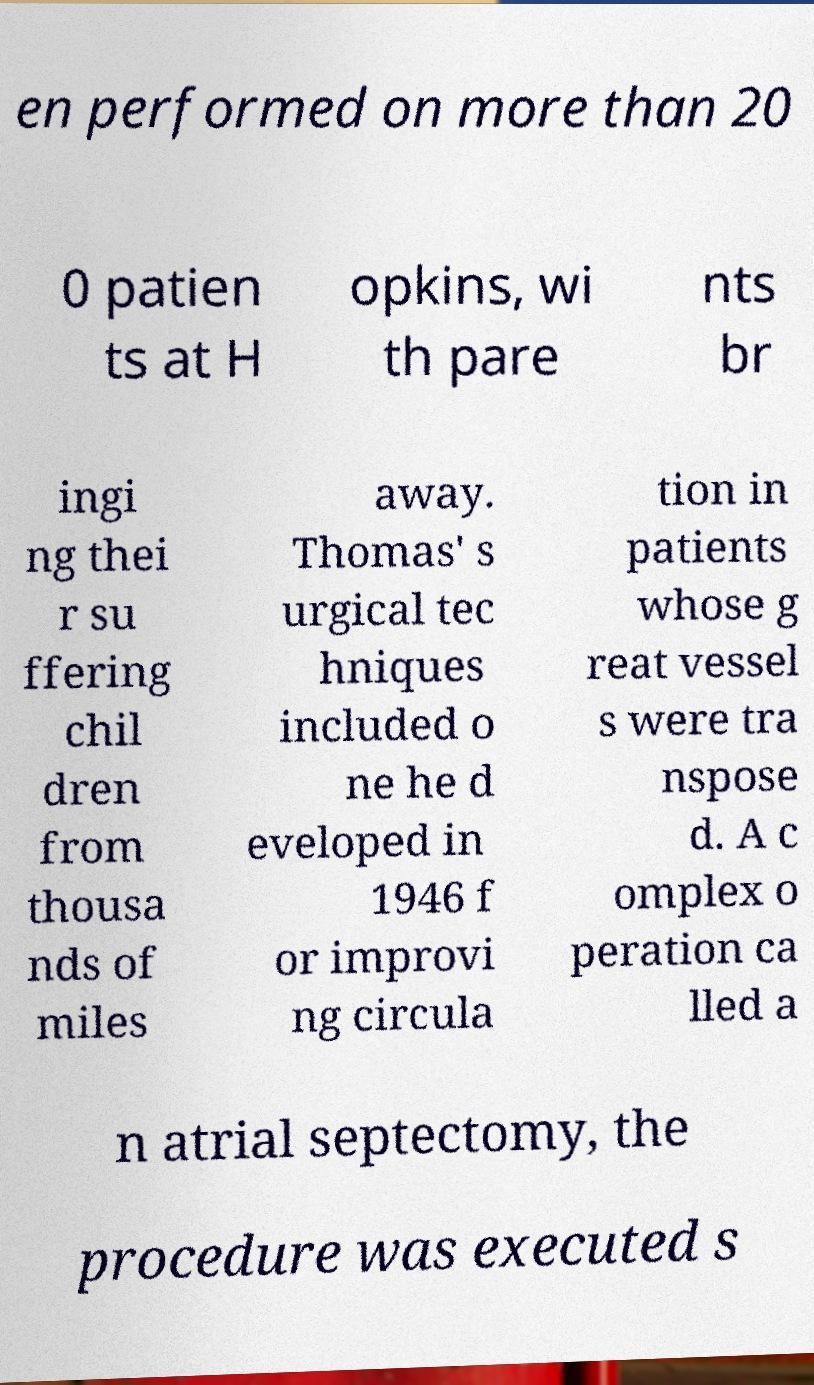There's text embedded in this image that I need extracted. Can you transcribe it verbatim? en performed on more than 20 0 patien ts at H opkins, wi th pare nts br ingi ng thei r su ffering chil dren from thousa nds of miles away. Thomas' s urgical tec hniques included o ne he d eveloped in 1946 f or improvi ng circula tion in patients whose g reat vessel s were tra nspose d. A c omplex o peration ca lled a n atrial septectomy, the procedure was executed s 